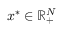Convert formula to latex. <formula><loc_0><loc_0><loc_500><loc_500>{ \boldsymbol x } ^ { * } \in { \mathbb { R } } _ { + } ^ { N }</formula> 